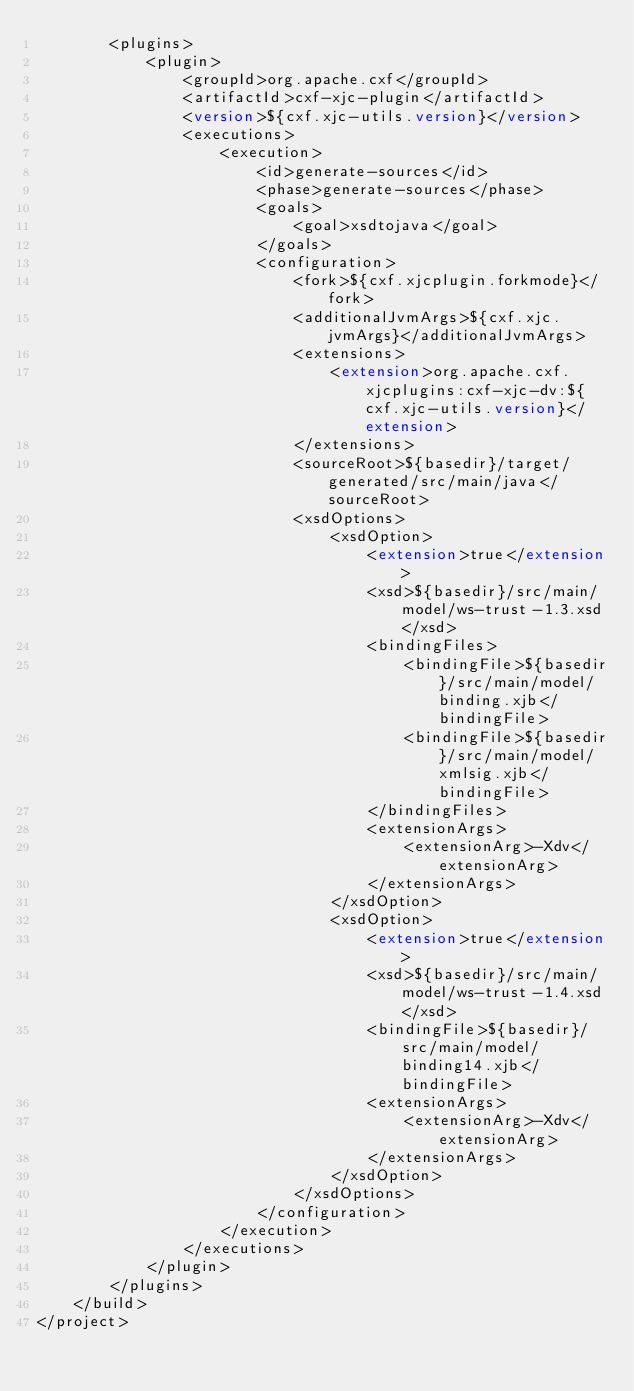Convert code to text. <code><loc_0><loc_0><loc_500><loc_500><_XML_>        <plugins>
            <plugin>
                <groupId>org.apache.cxf</groupId>
                <artifactId>cxf-xjc-plugin</artifactId>
                <version>${cxf.xjc-utils.version}</version>
                <executions>
                    <execution>
                        <id>generate-sources</id>
                        <phase>generate-sources</phase>
                        <goals>
                            <goal>xsdtojava</goal>
                        </goals>
                        <configuration>
                            <fork>${cxf.xjcplugin.forkmode}</fork>
                            <additionalJvmArgs>${cxf.xjc.jvmArgs}</additionalJvmArgs>
                            <extensions>
                                <extension>org.apache.cxf.xjcplugins:cxf-xjc-dv:${cxf.xjc-utils.version}</extension>
                            </extensions>
                            <sourceRoot>${basedir}/target/generated/src/main/java</sourceRoot>
                            <xsdOptions>
                                <xsdOption>
                                    <extension>true</extension>
                                    <xsd>${basedir}/src/main/model/ws-trust-1.3.xsd</xsd>
                                    <bindingFiles>
                                        <bindingFile>${basedir}/src/main/model/binding.xjb</bindingFile>
                                        <bindingFile>${basedir}/src/main/model/xmlsig.xjb</bindingFile>
                                    </bindingFiles>
                                    <extensionArgs>
                                        <extensionArg>-Xdv</extensionArg>
                                    </extensionArgs>
                                </xsdOption>
                                <xsdOption>
                                    <extension>true</extension>
                                    <xsd>${basedir}/src/main/model/ws-trust-1.4.xsd</xsd>
                                    <bindingFile>${basedir}/src/main/model/binding14.xjb</bindingFile>
                                    <extensionArgs>
                                        <extensionArg>-Xdv</extensionArg>
                                    </extensionArgs>
                                </xsdOption>
                            </xsdOptions>
                        </configuration>
                    </execution>
                </executions>
            </plugin>
        </plugins>
    </build>
</project>
</code> 